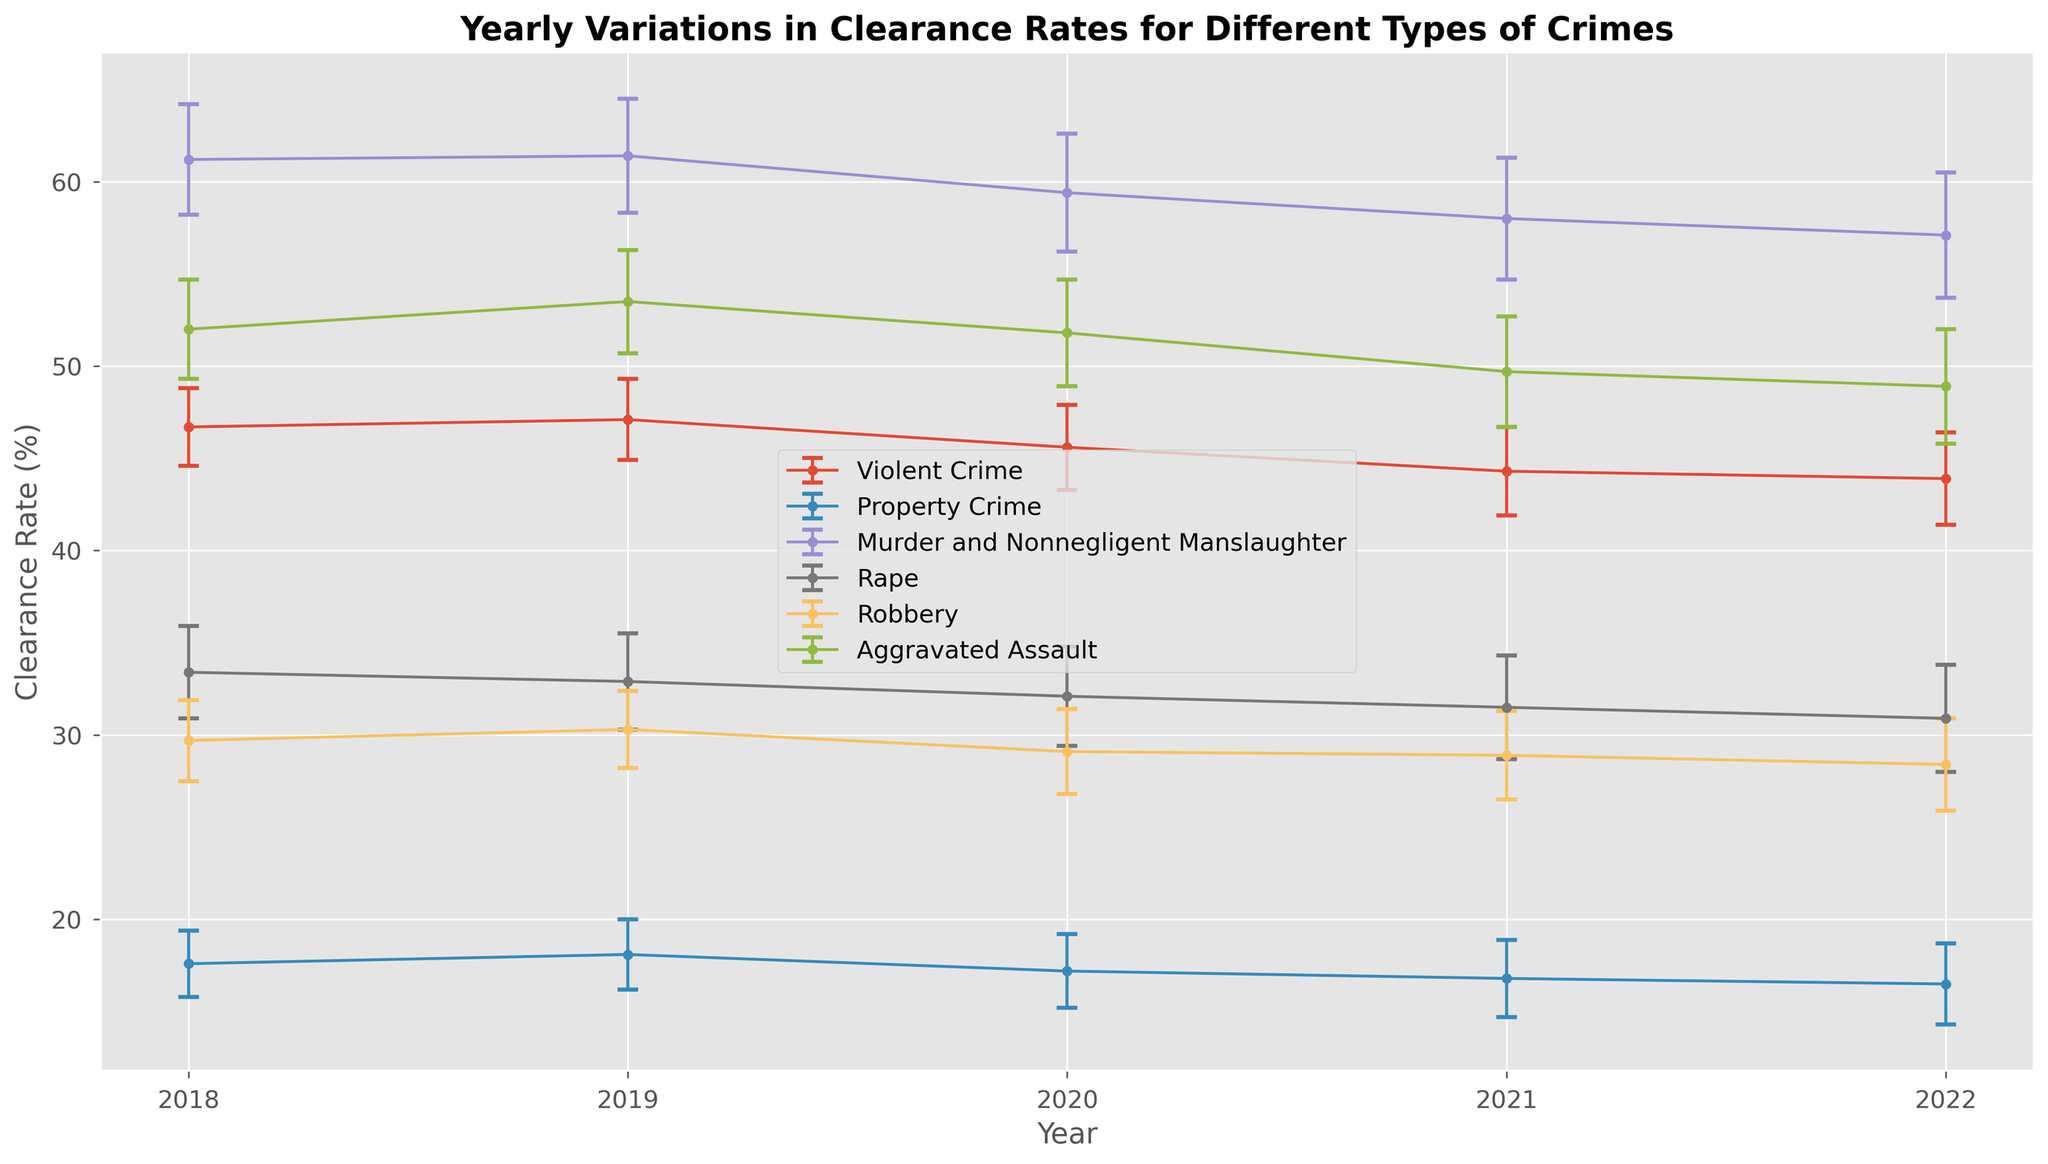What is the clearance rate trend for Violent Crimes from 2018 to 2022? The clearance rates for Violent Crimes over the years are: 46.7% (2018), 47.1% (2019), 45.6% (2020), 44.3% (2021), and 43.9% (2022). These values show a decreasing trend.
Answer: Decreasing Which year had the highest clearance rate for Murder and Nonnegligent Manslaughter? Observing the clearance rates for Murder and Nonnegligent Manslaughter: 61.2% (2018), 61.4% (2019), 59.4% (2020), 58.0% (2021), and 57.1% (2022), the highest rate is in 2019 with 61.4%.
Answer: 2019 Compare the clearance rates of Property Crimes and Aggravated Assault in 2020. Which crime type had a higher clearance rate? In 2020, the clearance rate for Property Crimes was 17.2%, while for Aggravated Assault it was 51.8%. Comparing these values, Aggravated Assault had a higher clearance rate.
Answer: Aggravated Assault What is the average clearance rate for Robbery across all the years presented? The clearance rates for Robbery from 2018 to 2022 are 29.7%, 30.3%, 29.1%, 28.9%, and 28.4%. Adding these rates gives 146.4%. Dividing by 5 years, the average clearance rate is 29.3%.
Answer: 29.3% Between Rape and Robbery, which crime type showed a greater decrease in clearance rate from 2018 to 2022? The clearance rate for Rape decreased from 33.4% in 2018 to 30.9% in 2022, a decrease of 2.5%. For Robbery, it decreased from 29.7% in 2018 to 28.4% in 2022, a decrease of 1.3%. Therefore, Rape showed a greater decrease.
Answer: Rape What is the lowest clearance rate recorded for Property Crime from 2018 to 2022 and in which year? The clearance rates for Property Crimes over the years are 17.6% (2018), 18.1% (2019), 17.2% (2020), 16.8% (2021), and 16.5% (2022). The lowest rate is 16.5% in 2022.
Answer: 16.5% in 2022 In which year did Violent Crimes have the smallest error margin in their clearance rate, and what was the value? The error margins for Violent Crimes are 2.1 (2018), 2.2 (2019), 2.3 (2020), 2.4 (2021), and 2.5 (2022). The smallest error margin is 2.1 in 2018.
Answer: 2018, 2.1 How did the clearance rate for Rape change from 2019 to 2022? The clearance rate for Rape changed from 32.9% in 2019, to 32.1% in 2020, to 31.5% in 2021, and to 30.9% in 2022, showing a gradual decrease each year.
Answer: Decrease What is the difference in clearance rates between the highest and lowest values for Murder and Nonnegligent Manslaughter from 2018 to 2022? The highest clearance rate for Murder and Nonnegligent Manslaughter is 61.4% (2019) and the lowest is 57.1% (2022). The difference is 61.4% - 57.1% = 4.3%.
Answer: 4.3% What is the median clearance rate for Aggravated Assault from 2018 to 2022? The clearance rates for Aggravated Assault from 2018 to 2022 are 52.0%, 53.5%, 51.8%, 49.7%, and 48.9%. Arranging them in ascending order: 48.9%, 49.7%, 51.8%, 52.0%, and 53.5%, the median value is 51.8%.
Answer: 51.8% 